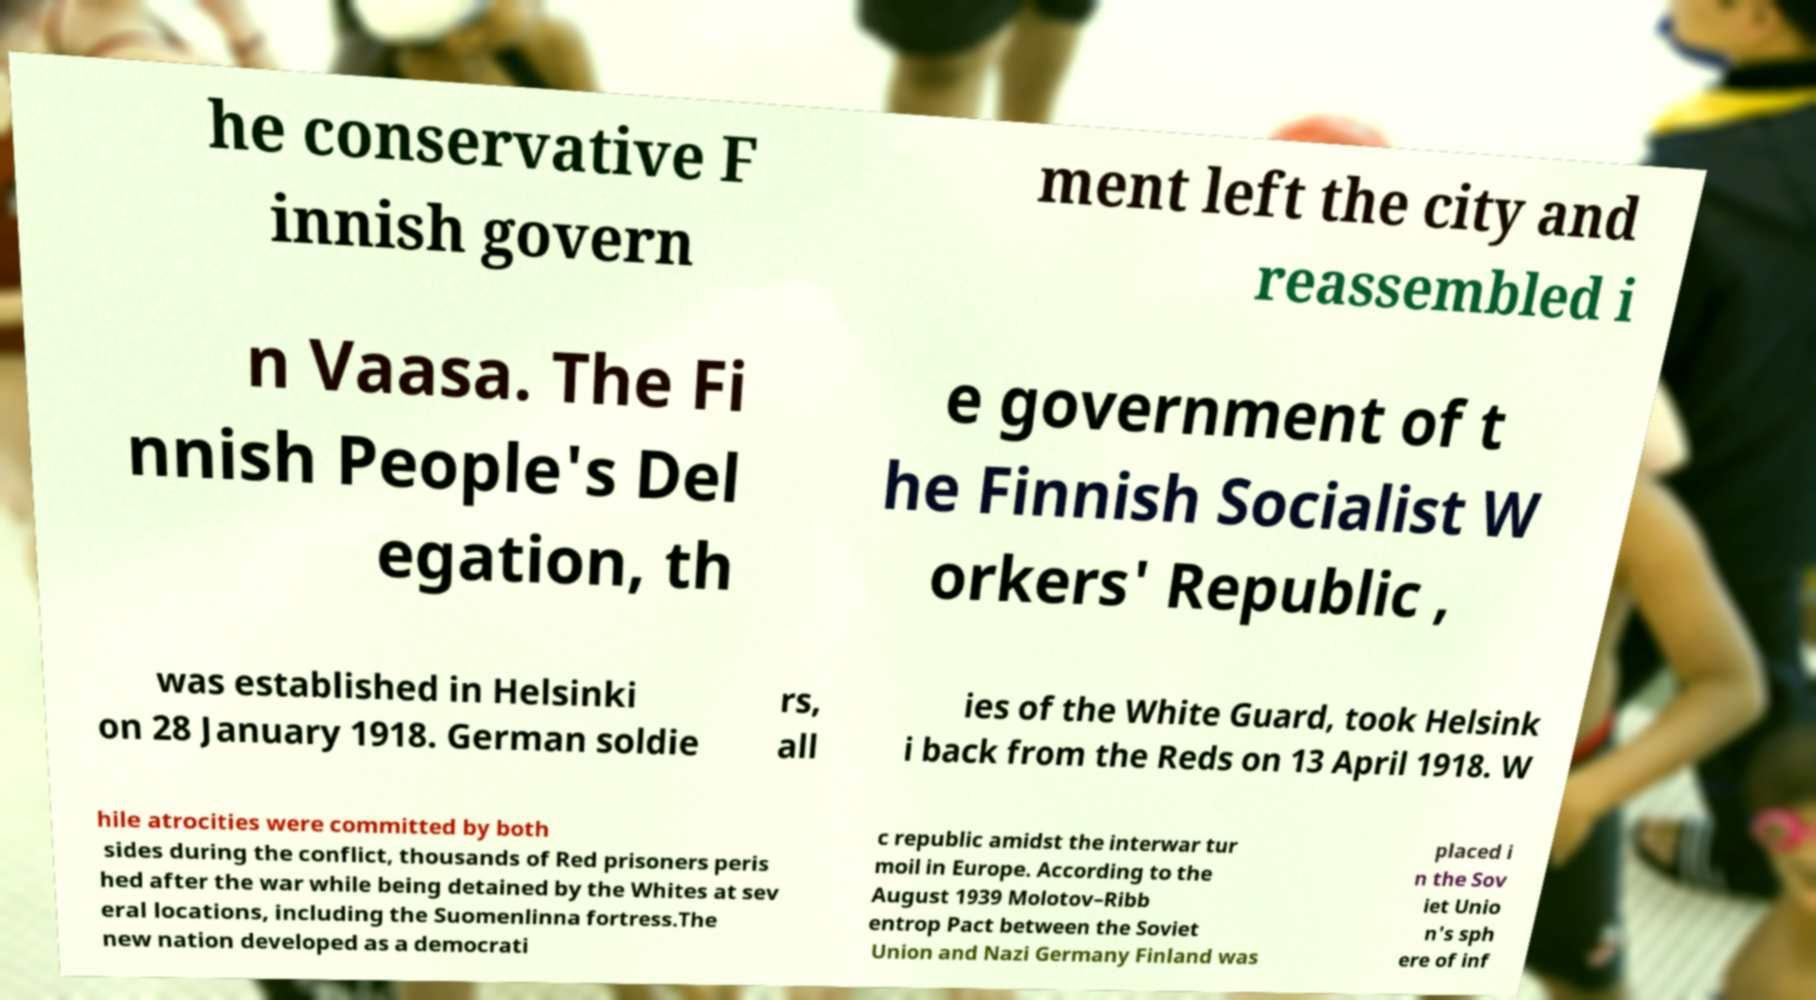Please read and relay the text visible in this image. What does it say? he conservative F innish govern ment left the city and reassembled i n Vaasa. The Fi nnish People's Del egation, th e government of t he Finnish Socialist W orkers' Republic , was established in Helsinki on 28 January 1918. German soldie rs, all ies of the White Guard, took Helsink i back from the Reds on 13 April 1918. W hile atrocities were committed by both sides during the conflict, thousands of Red prisoners peris hed after the war while being detained by the Whites at sev eral locations, including the Suomenlinna fortress.The new nation developed as a democrati c republic amidst the interwar tur moil in Europe. According to the August 1939 Molotov–Ribb entrop Pact between the Soviet Union and Nazi Germany Finland was placed i n the Sov iet Unio n's sph ere of inf 